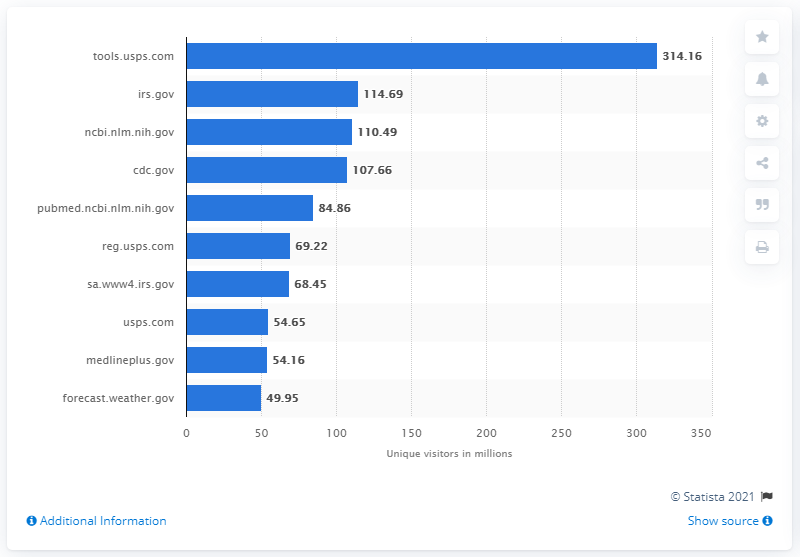Outline some significant characteristics in this image. The CDC's website recorded 107,660 visits in the preceding 30-day period. 